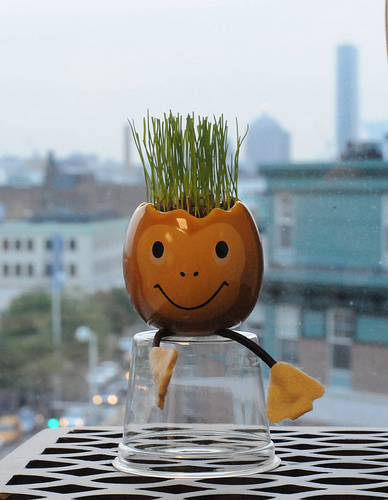<image>
Is there a flower pot on the cup? Yes. Looking at the image, I can see the flower pot is positioned on top of the cup, with the cup providing support. 